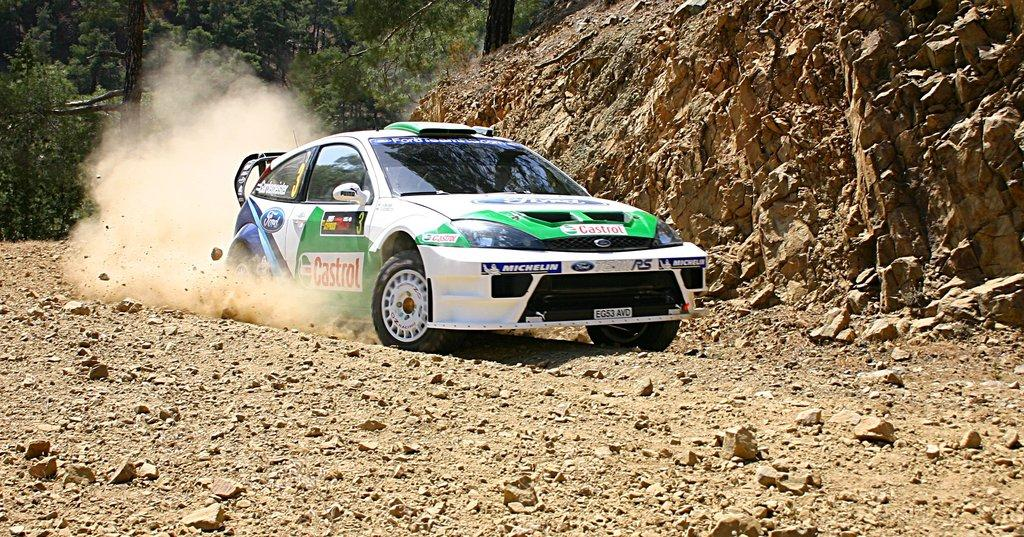What is the main subject of the image? There is a car in the image. What can be seen on the ground in the image? There are stones on the ground in the image. What other natural elements are present in the image? There are rocks and trees in the background of the image. What is the condition of the environment in the image? There is dust visible in the image, which suggests a dry or dusty environment. Can you see a note being passed between the trees in the image? There is no note or any indication of a note being passed between the trees in the image. 